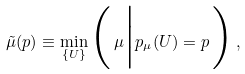<formula> <loc_0><loc_0><loc_500><loc_500>\tilde { \mu } ( p ) \equiv \min _ { \{ U \} } \Big ( \, \mu \Big | p _ { \mu } ( U ) = p \, \Big ) \, ,</formula> 